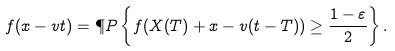<formula> <loc_0><loc_0><loc_500><loc_500>f ( x - v t ) = \P P \left \{ f ( X ( T ) + x - v ( t - T ) ) \geq \frac { 1 - \varepsilon } { 2 } \right \} .</formula> 